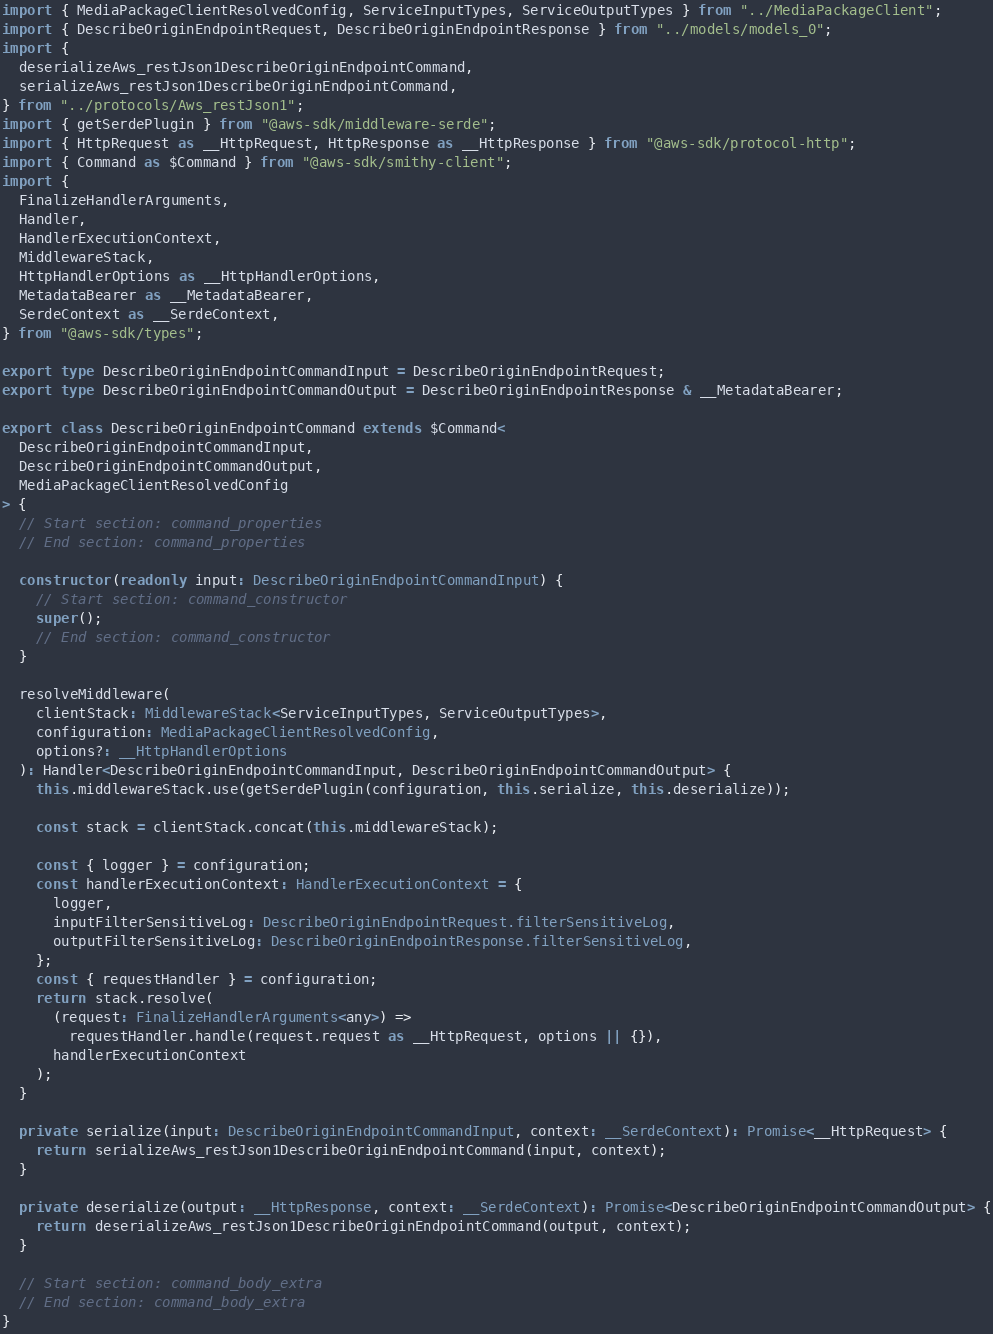<code> <loc_0><loc_0><loc_500><loc_500><_TypeScript_>import { MediaPackageClientResolvedConfig, ServiceInputTypes, ServiceOutputTypes } from "../MediaPackageClient";
import { DescribeOriginEndpointRequest, DescribeOriginEndpointResponse } from "../models/models_0";
import {
  deserializeAws_restJson1DescribeOriginEndpointCommand,
  serializeAws_restJson1DescribeOriginEndpointCommand,
} from "../protocols/Aws_restJson1";
import { getSerdePlugin } from "@aws-sdk/middleware-serde";
import { HttpRequest as __HttpRequest, HttpResponse as __HttpResponse } from "@aws-sdk/protocol-http";
import { Command as $Command } from "@aws-sdk/smithy-client";
import {
  FinalizeHandlerArguments,
  Handler,
  HandlerExecutionContext,
  MiddlewareStack,
  HttpHandlerOptions as __HttpHandlerOptions,
  MetadataBearer as __MetadataBearer,
  SerdeContext as __SerdeContext,
} from "@aws-sdk/types";

export type DescribeOriginEndpointCommandInput = DescribeOriginEndpointRequest;
export type DescribeOriginEndpointCommandOutput = DescribeOriginEndpointResponse & __MetadataBearer;

export class DescribeOriginEndpointCommand extends $Command<
  DescribeOriginEndpointCommandInput,
  DescribeOriginEndpointCommandOutput,
  MediaPackageClientResolvedConfig
> {
  // Start section: command_properties
  // End section: command_properties

  constructor(readonly input: DescribeOriginEndpointCommandInput) {
    // Start section: command_constructor
    super();
    // End section: command_constructor
  }

  resolveMiddleware(
    clientStack: MiddlewareStack<ServiceInputTypes, ServiceOutputTypes>,
    configuration: MediaPackageClientResolvedConfig,
    options?: __HttpHandlerOptions
  ): Handler<DescribeOriginEndpointCommandInput, DescribeOriginEndpointCommandOutput> {
    this.middlewareStack.use(getSerdePlugin(configuration, this.serialize, this.deserialize));

    const stack = clientStack.concat(this.middlewareStack);

    const { logger } = configuration;
    const handlerExecutionContext: HandlerExecutionContext = {
      logger,
      inputFilterSensitiveLog: DescribeOriginEndpointRequest.filterSensitiveLog,
      outputFilterSensitiveLog: DescribeOriginEndpointResponse.filterSensitiveLog,
    };
    const { requestHandler } = configuration;
    return stack.resolve(
      (request: FinalizeHandlerArguments<any>) =>
        requestHandler.handle(request.request as __HttpRequest, options || {}),
      handlerExecutionContext
    );
  }

  private serialize(input: DescribeOriginEndpointCommandInput, context: __SerdeContext): Promise<__HttpRequest> {
    return serializeAws_restJson1DescribeOriginEndpointCommand(input, context);
  }

  private deserialize(output: __HttpResponse, context: __SerdeContext): Promise<DescribeOriginEndpointCommandOutput> {
    return deserializeAws_restJson1DescribeOriginEndpointCommand(output, context);
  }

  // Start section: command_body_extra
  // End section: command_body_extra
}
</code> 